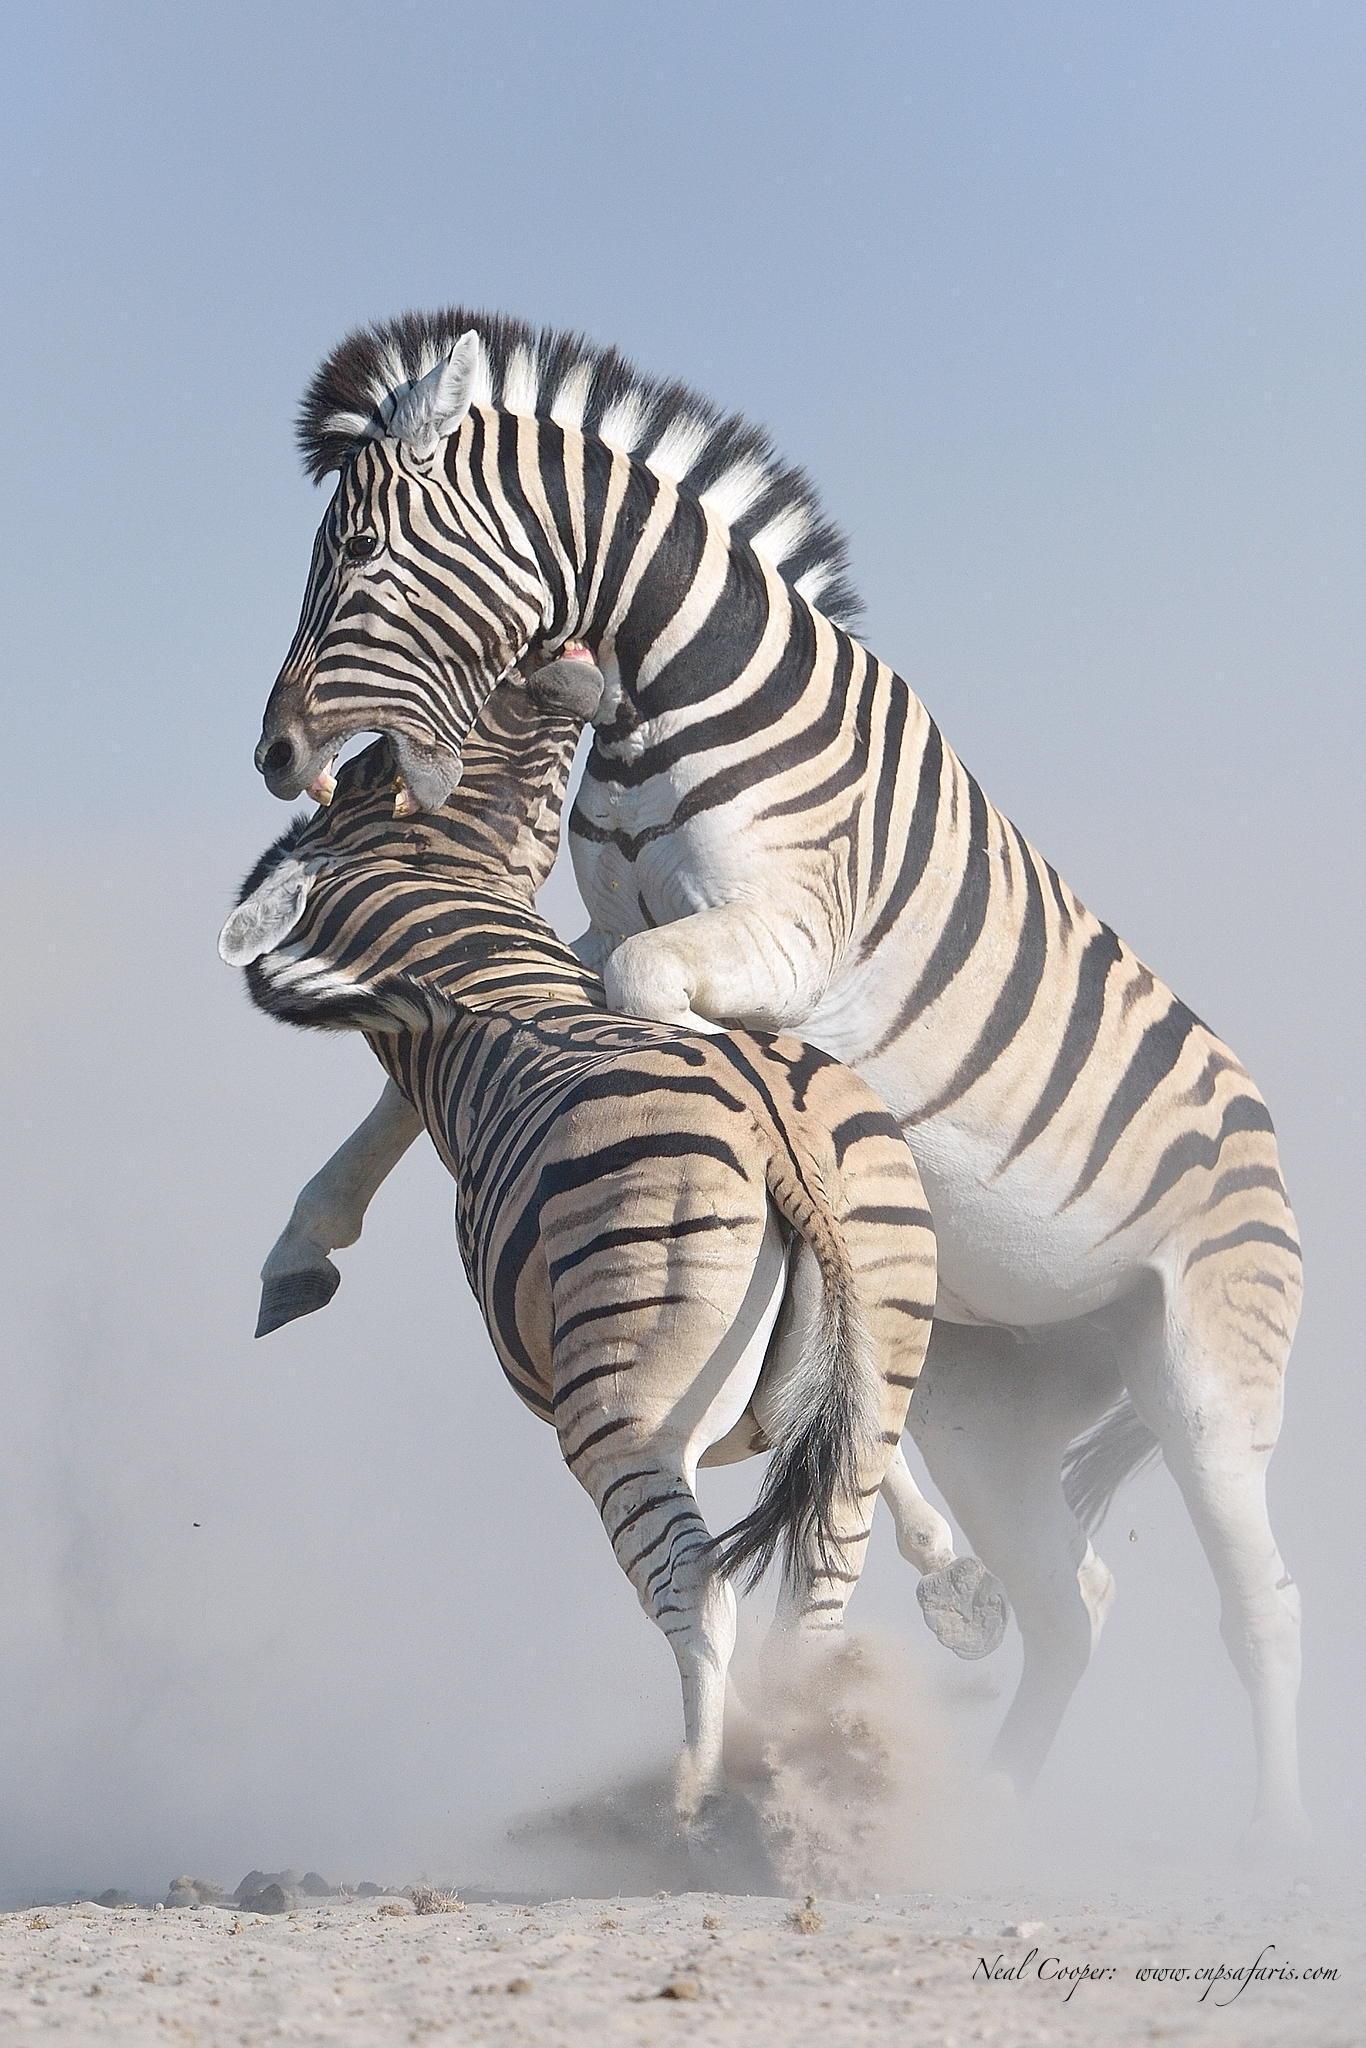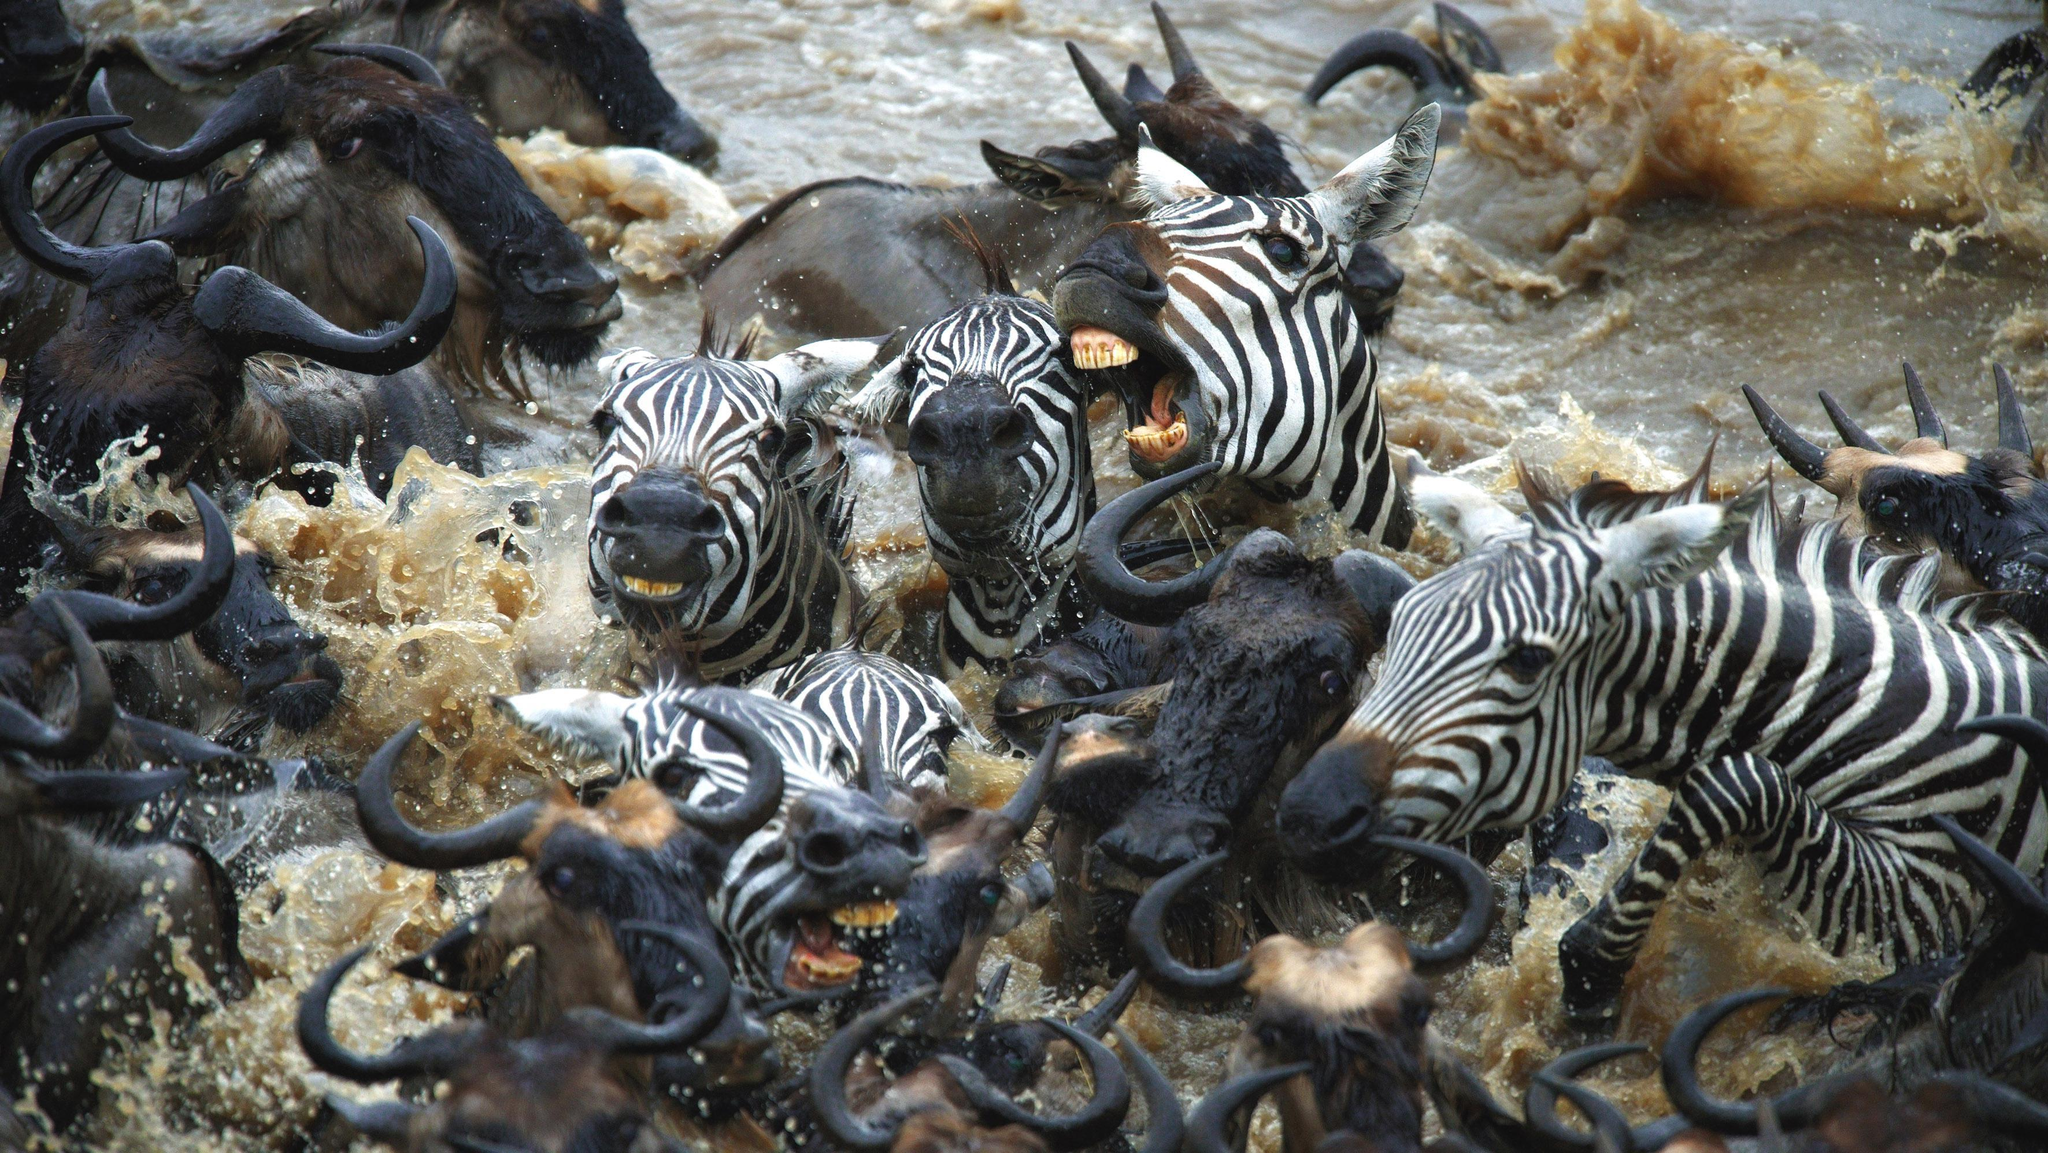The first image is the image on the left, the second image is the image on the right. Evaluate the accuracy of this statement regarding the images: "One of the images shows a zebra in close contact with a mammal of another species.". Is it true? Answer yes or no. Yes. The first image is the image on the left, the second image is the image on the right. For the images displayed, is the sentence "The photo on the right shows an animal that is not a zebra, and the one on the left shows at least two zebras in a dusty environment." factually correct? Answer yes or no. Yes. 